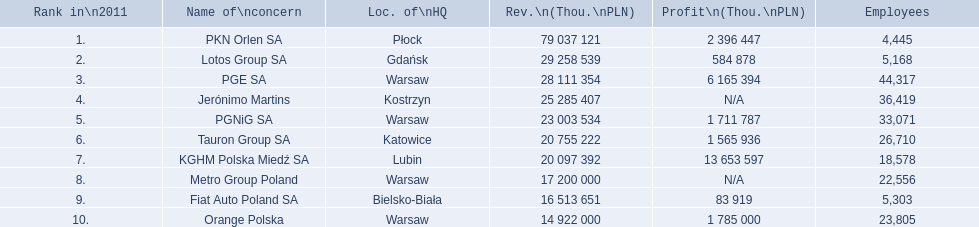Which concern's headquarters are located in warsaw? PGE SA, PGNiG SA, Metro Group Poland. Which of these listed a profit? PGE SA, PGNiG SA. Of these how many employees are in the concern with the lowest profit? 33,071. 